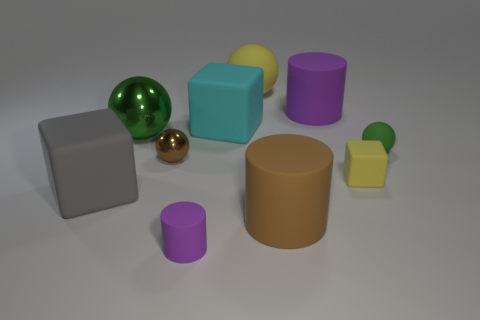What number of blue balls have the same size as the green rubber object?
Your answer should be very brief. 0. What color is the small thing that is both on the left side of the tiny yellow rubber thing and in front of the tiny brown ball?
Provide a succinct answer. Purple. What number of things are either blocks or large green rubber blocks?
Your answer should be very brief. 3. How many big things are green matte things or yellow blocks?
Your response must be concise. 0. Is there any other thing that has the same color as the small matte cylinder?
Provide a succinct answer. Yes. What size is the rubber block that is right of the big green thing and in front of the cyan matte block?
Your answer should be very brief. Small. Is the color of the matte sphere that is in front of the yellow ball the same as the tiny rubber cylinder on the left side of the small yellow object?
Provide a short and direct response. No. What number of other objects are there of the same material as the big gray thing?
Provide a succinct answer. 7. There is a rubber object that is behind the large brown cylinder and on the left side of the cyan block; what is its shape?
Your response must be concise. Cube. Do the big matte ball and the rubber cylinder that is behind the small green rubber object have the same color?
Provide a succinct answer. No. 